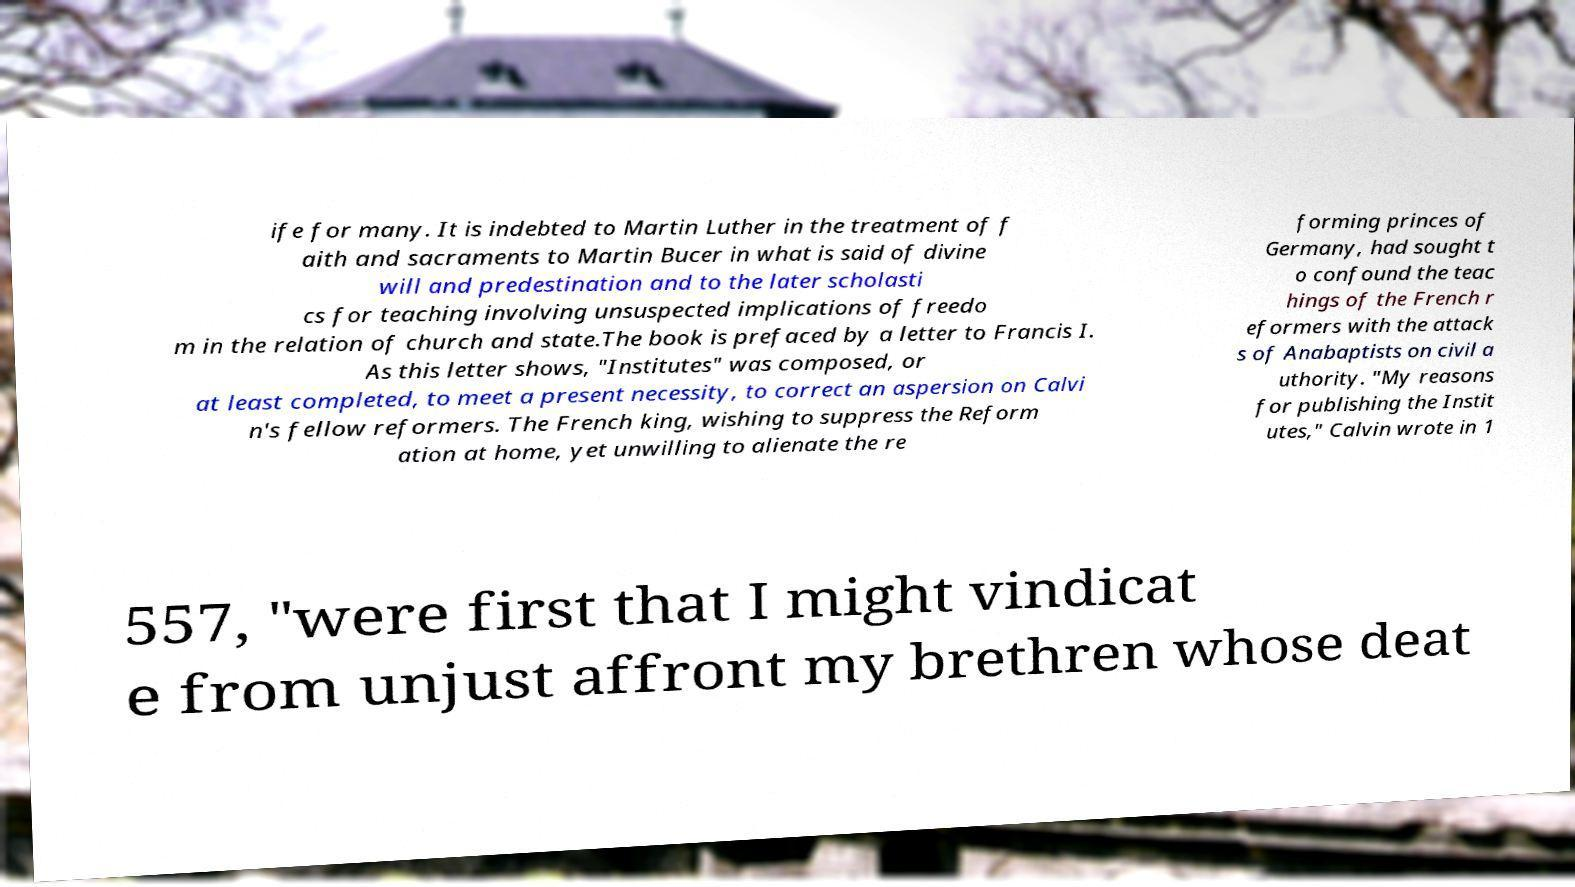For documentation purposes, I need the text within this image transcribed. Could you provide that? ife for many. It is indebted to Martin Luther in the treatment of f aith and sacraments to Martin Bucer in what is said of divine will and predestination and to the later scholasti cs for teaching involving unsuspected implications of freedo m in the relation of church and state.The book is prefaced by a letter to Francis I. As this letter shows, "Institutes" was composed, or at least completed, to meet a present necessity, to correct an aspersion on Calvi n's fellow reformers. The French king, wishing to suppress the Reform ation at home, yet unwilling to alienate the re forming princes of Germany, had sought t o confound the teac hings of the French r eformers with the attack s of Anabaptists on civil a uthority. "My reasons for publishing the Instit utes," Calvin wrote in 1 557, "were first that I might vindicat e from unjust affront my brethren whose deat 